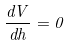Convert formula to latex. <formula><loc_0><loc_0><loc_500><loc_500>\frac { d V } { d h } = 0</formula> 